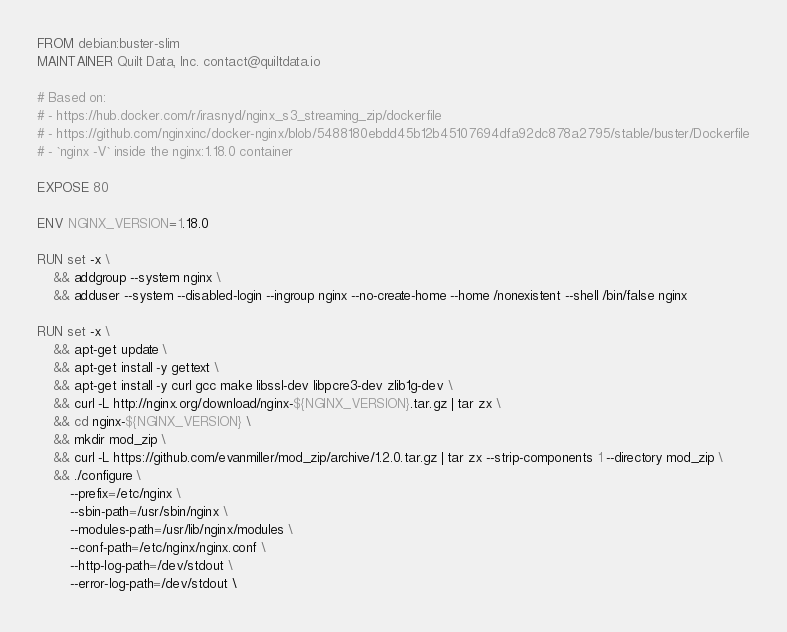Convert code to text. <code><loc_0><loc_0><loc_500><loc_500><_Dockerfile_>FROM debian:buster-slim
MAINTAINER Quilt Data, Inc. contact@quiltdata.io

# Based on:
# - https://hub.docker.com/r/irasnyd/nginx_s3_streaming_zip/dockerfile
# - https://github.com/nginxinc/docker-nginx/blob/5488180ebdd45b12b45107694dfa92dc878a2795/stable/buster/Dockerfile
# - `nginx -V` inside the nginx:1.18.0 container

EXPOSE 80

ENV NGINX_VERSION=1.18.0

RUN set -x \
    && addgroup --system nginx \
    && adduser --system --disabled-login --ingroup nginx --no-create-home --home /nonexistent --shell /bin/false nginx

RUN set -x \
    && apt-get update \
    && apt-get install -y gettext \
    && apt-get install -y curl gcc make libssl-dev libpcre3-dev zlib1g-dev \
    && curl -L http://nginx.org/download/nginx-${NGINX_VERSION}.tar.gz | tar zx \
    && cd nginx-${NGINX_VERSION} \
    && mkdir mod_zip \
    && curl -L https://github.com/evanmiller/mod_zip/archive/1.2.0.tar.gz | tar zx --strip-components 1 --directory mod_zip \
    && ./configure \
        --prefix=/etc/nginx \
        --sbin-path=/usr/sbin/nginx \
        --modules-path=/usr/lib/nginx/modules \
        --conf-path=/etc/nginx/nginx.conf \
        --http-log-path=/dev/stdout \
        --error-log-path=/dev/stdout \</code> 